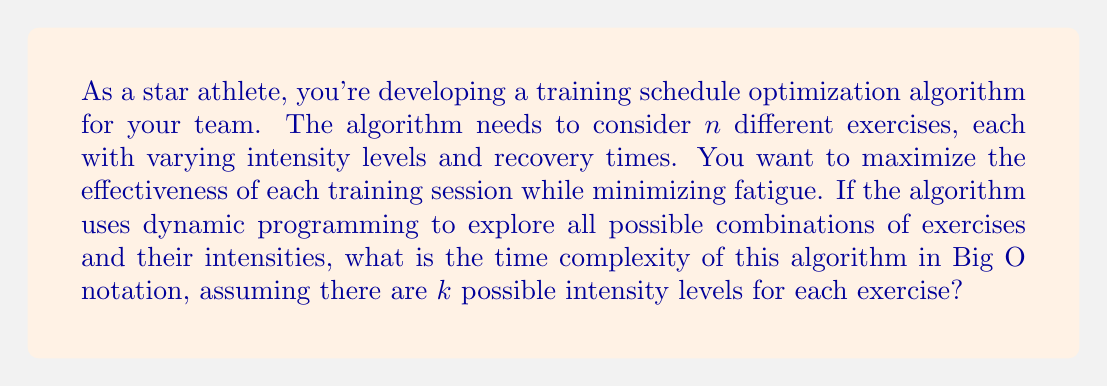What is the answer to this math problem? To solve this problem, let's break it down step by step:

1) In this scenario, we have $n$ exercises, each with $k$ possible intensity levels.

2) Dynamic programming typically involves building a table of solutions for subproblems. In this case, our subproblems would be the optimal schedules for different subsets of exercises.

3) For each exercise, we need to consider $k$ intensity levels. This means for each state in our dynamic programming table, we have $k$ choices.

4) The number of possible states in our dynamic programming table is determined by the number of possible subsets of exercises. With $n$ exercises, we have $2^n$ subsets.

5) For each of these $2^n$ states, we need to consider $k$ choices for the current exercise.

6) Therefore, the total number of operations our algorithm needs to perform is proportional to $2^n * k$.

7) In Big O notation, we typically express complexity in terms of the input size. Here, $n$ is our primary input size (number of exercises), while $k$ can be considered a constant factor.

8) Thus, even though $k$ affects the running time, in Big O notation we express this as $O(2^n)$.

This exponential time complexity $O(2^n)$ is typical for algorithms that explore all subsets of the input, which is often the case in optimization problems solved by dynamic programming.
Answer: $O(2^n)$ 